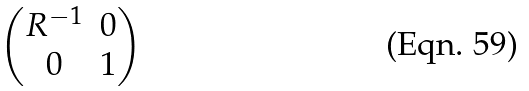Convert formula to latex. <formula><loc_0><loc_0><loc_500><loc_500>\begin{pmatrix} R ^ { - 1 } & 0 \\ 0 & 1 \end{pmatrix}</formula> 